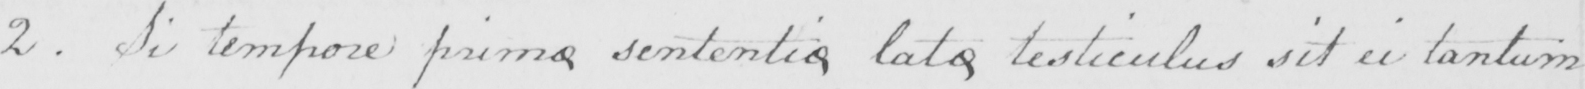Please provide the text content of this handwritten line. 2 . Si tempore primo sententio lato testiculus sit ei tantum 